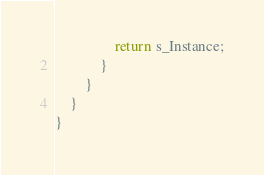Convert code to text. <code><loc_0><loc_0><loc_500><loc_500><_C#_>                return s_Instance;
            }
        }
    }
}
</code> 